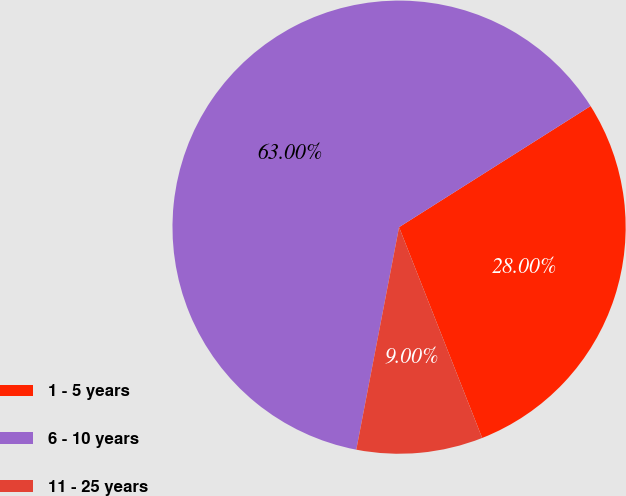Convert chart to OTSL. <chart><loc_0><loc_0><loc_500><loc_500><pie_chart><fcel>1 - 5 years<fcel>6 - 10 years<fcel>11 - 25 years<nl><fcel>28.0%<fcel>63.0%<fcel>9.0%<nl></chart> 